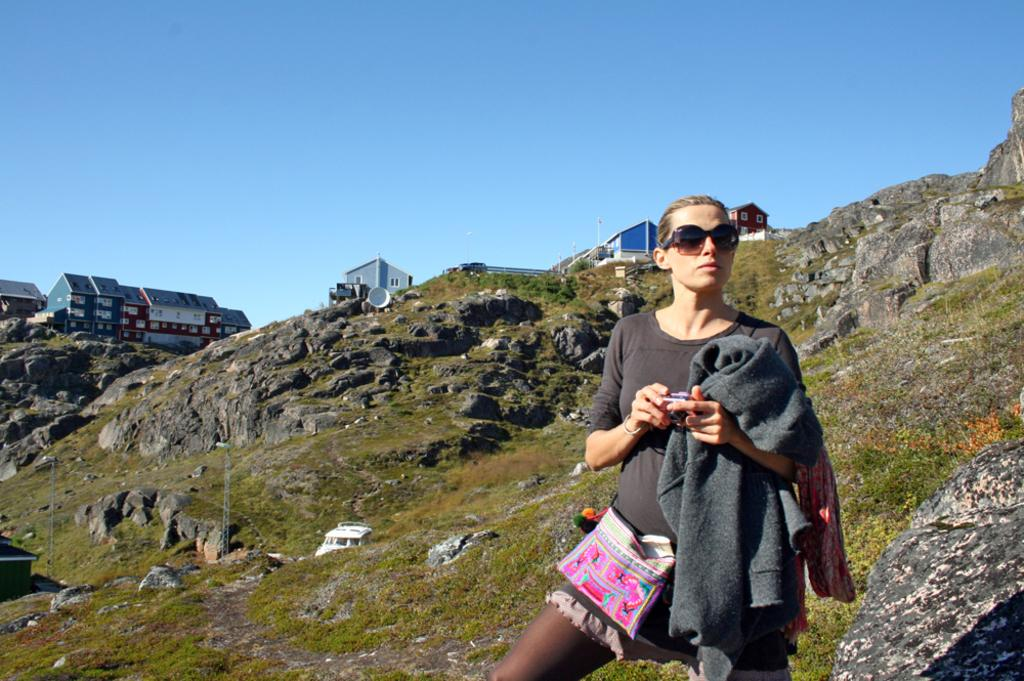Who is the main subject in the image? There is a girl in the image. What is the girl wearing? The girl is wearing a grey t-shirt. What is the girl holding in her hand? The girl is holding a hoodie in her hand. What can be seen in the background of the image? There are trees, a mountain, and shed houses on a hill visible in the background of the image. Where is the airport located in the image? There is no airport present in the image. How many trucks can be seen in the image? There are no trucks visible in the image. 